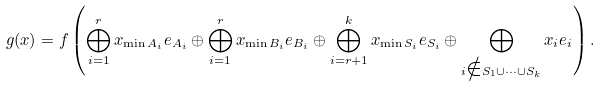Convert formula to latex. <formula><loc_0><loc_0><loc_500><loc_500>\ g ( x ) = f \left ( \bigoplus _ { i = 1 } ^ { r } x _ { \min A _ { i } } e _ { A _ { i } } \oplus \bigoplus _ { i = 1 } ^ { r } x _ { \min B _ { i } } e _ { B _ { i } } \oplus \bigoplus _ { i = r + 1 } ^ { k } x _ { \min S _ { i } } e _ { S _ { i } } \oplus \bigoplus _ { i \notin S _ { 1 } \cup \cdots \cup S _ { k } } x _ { i } e _ { i } \right ) .</formula> 